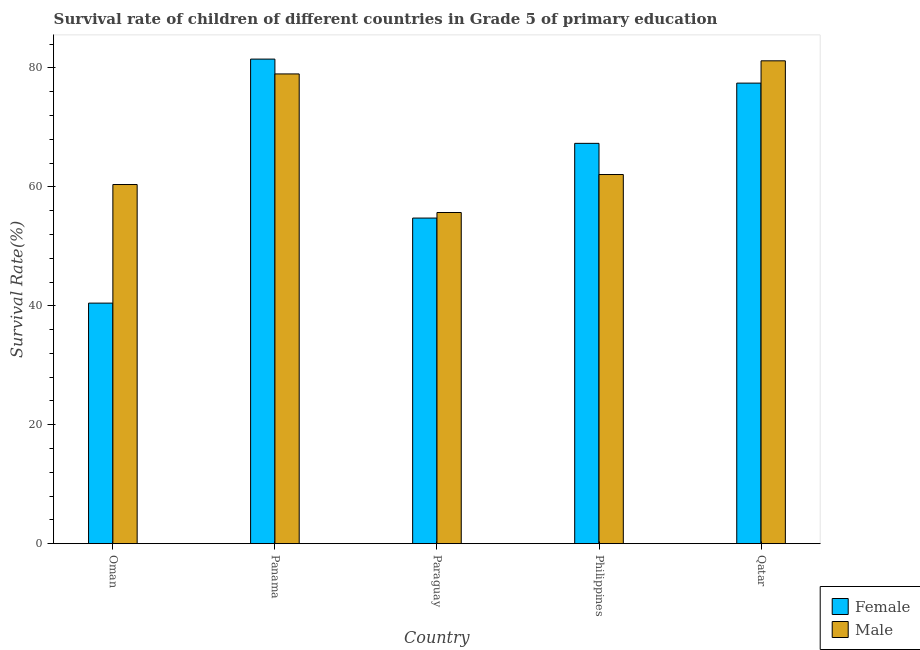How many groups of bars are there?
Give a very brief answer. 5. Are the number of bars per tick equal to the number of legend labels?
Your response must be concise. Yes. Are the number of bars on each tick of the X-axis equal?
Your answer should be very brief. Yes. What is the label of the 1st group of bars from the left?
Your answer should be very brief. Oman. What is the survival rate of female students in primary education in Oman?
Offer a very short reply. 40.45. Across all countries, what is the maximum survival rate of female students in primary education?
Offer a very short reply. 81.48. Across all countries, what is the minimum survival rate of female students in primary education?
Your answer should be compact. 40.45. In which country was the survival rate of female students in primary education maximum?
Ensure brevity in your answer.  Panama. In which country was the survival rate of female students in primary education minimum?
Keep it short and to the point. Oman. What is the total survival rate of male students in primary education in the graph?
Your answer should be compact. 338.33. What is the difference between the survival rate of male students in primary education in Philippines and that in Qatar?
Ensure brevity in your answer.  -19.12. What is the difference between the survival rate of female students in primary education in Paraguay and the survival rate of male students in primary education in Qatar?
Your response must be concise. -26.44. What is the average survival rate of male students in primary education per country?
Give a very brief answer. 67.67. What is the difference between the survival rate of male students in primary education and survival rate of female students in primary education in Philippines?
Offer a terse response. -5.24. In how many countries, is the survival rate of male students in primary education greater than 48 %?
Ensure brevity in your answer.  5. What is the ratio of the survival rate of female students in primary education in Paraguay to that in Philippines?
Give a very brief answer. 0.81. What is the difference between the highest and the second highest survival rate of male students in primary education?
Your answer should be compact. 2.21. What is the difference between the highest and the lowest survival rate of female students in primary education?
Offer a very short reply. 41.03. Is the sum of the survival rate of male students in primary education in Paraguay and Philippines greater than the maximum survival rate of female students in primary education across all countries?
Keep it short and to the point. Yes. What does the 1st bar from the right in Qatar represents?
Keep it short and to the point. Male. Are all the bars in the graph horizontal?
Provide a succinct answer. No. Are the values on the major ticks of Y-axis written in scientific E-notation?
Your answer should be very brief. No. Does the graph contain any zero values?
Provide a short and direct response. No. Does the graph contain grids?
Your answer should be compact. No. What is the title of the graph?
Offer a very short reply. Survival rate of children of different countries in Grade 5 of primary education. What is the label or title of the Y-axis?
Keep it short and to the point. Survival Rate(%). What is the Survival Rate(%) in Female in Oman?
Provide a succinct answer. 40.45. What is the Survival Rate(%) of Male in Oman?
Your response must be concise. 60.39. What is the Survival Rate(%) in Female in Panama?
Your response must be concise. 81.48. What is the Survival Rate(%) of Male in Panama?
Your answer should be compact. 78.99. What is the Survival Rate(%) in Female in Paraguay?
Keep it short and to the point. 54.75. What is the Survival Rate(%) in Male in Paraguay?
Your answer should be very brief. 55.69. What is the Survival Rate(%) of Female in Philippines?
Ensure brevity in your answer.  67.32. What is the Survival Rate(%) of Male in Philippines?
Your response must be concise. 62.07. What is the Survival Rate(%) of Female in Qatar?
Your answer should be compact. 77.44. What is the Survival Rate(%) in Male in Qatar?
Your answer should be very brief. 81.19. Across all countries, what is the maximum Survival Rate(%) of Female?
Your answer should be very brief. 81.48. Across all countries, what is the maximum Survival Rate(%) in Male?
Provide a succinct answer. 81.19. Across all countries, what is the minimum Survival Rate(%) of Female?
Give a very brief answer. 40.45. Across all countries, what is the minimum Survival Rate(%) of Male?
Ensure brevity in your answer.  55.69. What is the total Survival Rate(%) in Female in the graph?
Keep it short and to the point. 321.44. What is the total Survival Rate(%) in Male in the graph?
Offer a very short reply. 338.33. What is the difference between the Survival Rate(%) in Female in Oman and that in Panama?
Provide a short and direct response. -41.03. What is the difference between the Survival Rate(%) of Male in Oman and that in Panama?
Make the answer very short. -18.6. What is the difference between the Survival Rate(%) in Female in Oman and that in Paraguay?
Give a very brief answer. -14.3. What is the difference between the Survival Rate(%) of Male in Oman and that in Paraguay?
Offer a very short reply. 4.71. What is the difference between the Survival Rate(%) in Female in Oman and that in Philippines?
Offer a terse response. -26.87. What is the difference between the Survival Rate(%) of Male in Oman and that in Philippines?
Make the answer very short. -1.68. What is the difference between the Survival Rate(%) of Female in Oman and that in Qatar?
Ensure brevity in your answer.  -36.99. What is the difference between the Survival Rate(%) in Male in Oman and that in Qatar?
Provide a short and direct response. -20.8. What is the difference between the Survival Rate(%) in Female in Panama and that in Paraguay?
Make the answer very short. 26.73. What is the difference between the Survival Rate(%) in Male in Panama and that in Paraguay?
Offer a very short reply. 23.3. What is the difference between the Survival Rate(%) in Female in Panama and that in Philippines?
Make the answer very short. 14.17. What is the difference between the Survival Rate(%) in Male in Panama and that in Philippines?
Provide a short and direct response. 16.92. What is the difference between the Survival Rate(%) in Female in Panama and that in Qatar?
Your answer should be compact. 4.04. What is the difference between the Survival Rate(%) in Male in Panama and that in Qatar?
Provide a short and direct response. -2.21. What is the difference between the Survival Rate(%) of Female in Paraguay and that in Philippines?
Offer a terse response. -12.57. What is the difference between the Survival Rate(%) in Male in Paraguay and that in Philippines?
Keep it short and to the point. -6.39. What is the difference between the Survival Rate(%) in Female in Paraguay and that in Qatar?
Give a very brief answer. -22.69. What is the difference between the Survival Rate(%) of Male in Paraguay and that in Qatar?
Your answer should be very brief. -25.51. What is the difference between the Survival Rate(%) of Female in Philippines and that in Qatar?
Offer a terse response. -10.13. What is the difference between the Survival Rate(%) of Male in Philippines and that in Qatar?
Keep it short and to the point. -19.12. What is the difference between the Survival Rate(%) of Female in Oman and the Survival Rate(%) of Male in Panama?
Your answer should be very brief. -38.54. What is the difference between the Survival Rate(%) in Female in Oman and the Survival Rate(%) in Male in Paraguay?
Offer a very short reply. -15.24. What is the difference between the Survival Rate(%) of Female in Oman and the Survival Rate(%) of Male in Philippines?
Make the answer very short. -21.62. What is the difference between the Survival Rate(%) of Female in Oman and the Survival Rate(%) of Male in Qatar?
Provide a short and direct response. -40.74. What is the difference between the Survival Rate(%) in Female in Panama and the Survival Rate(%) in Male in Paraguay?
Offer a terse response. 25.8. What is the difference between the Survival Rate(%) of Female in Panama and the Survival Rate(%) of Male in Philippines?
Offer a very short reply. 19.41. What is the difference between the Survival Rate(%) in Female in Panama and the Survival Rate(%) in Male in Qatar?
Keep it short and to the point. 0.29. What is the difference between the Survival Rate(%) of Female in Paraguay and the Survival Rate(%) of Male in Philippines?
Offer a terse response. -7.32. What is the difference between the Survival Rate(%) of Female in Paraguay and the Survival Rate(%) of Male in Qatar?
Your answer should be compact. -26.44. What is the difference between the Survival Rate(%) in Female in Philippines and the Survival Rate(%) in Male in Qatar?
Offer a terse response. -13.88. What is the average Survival Rate(%) in Female per country?
Your answer should be very brief. 64.29. What is the average Survival Rate(%) in Male per country?
Your answer should be compact. 67.67. What is the difference between the Survival Rate(%) in Female and Survival Rate(%) in Male in Oman?
Offer a terse response. -19.94. What is the difference between the Survival Rate(%) in Female and Survival Rate(%) in Male in Panama?
Make the answer very short. 2.49. What is the difference between the Survival Rate(%) in Female and Survival Rate(%) in Male in Paraguay?
Keep it short and to the point. -0.94. What is the difference between the Survival Rate(%) in Female and Survival Rate(%) in Male in Philippines?
Offer a terse response. 5.24. What is the difference between the Survival Rate(%) in Female and Survival Rate(%) in Male in Qatar?
Make the answer very short. -3.75. What is the ratio of the Survival Rate(%) in Female in Oman to that in Panama?
Ensure brevity in your answer.  0.5. What is the ratio of the Survival Rate(%) of Male in Oman to that in Panama?
Ensure brevity in your answer.  0.76. What is the ratio of the Survival Rate(%) in Female in Oman to that in Paraguay?
Make the answer very short. 0.74. What is the ratio of the Survival Rate(%) in Male in Oman to that in Paraguay?
Ensure brevity in your answer.  1.08. What is the ratio of the Survival Rate(%) of Female in Oman to that in Philippines?
Ensure brevity in your answer.  0.6. What is the ratio of the Survival Rate(%) of Male in Oman to that in Philippines?
Make the answer very short. 0.97. What is the ratio of the Survival Rate(%) in Female in Oman to that in Qatar?
Keep it short and to the point. 0.52. What is the ratio of the Survival Rate(%) in Male in Oman to that in Qatar?
Keep it short and to the point. 0.74. What is the ratio of the Survival Rate(%) of Female in Panama to that in Paraguay?
Provide a succinct answer. 1.49. What is the ratio of the Survival Rate(%) in Male in Panama to that in Paraguay?
Provide a succinct answer. 1.42. What is the ratio of the Survival Rate(%) in Female in Panama to that in Philippines?
Keep it short and to the point. 1.21. What is the ratio of the Survival Rate(%) in Male in Panama to that in Philippines?
Offer a very short reply. 1.27. What is the ratio of the Survival Rate(%) in Female in Panama to that in Qatar?
Provide a succinct answer. 1.05. What is the ratio of the Survival Rate(%) in Male in Panama to that in Qatar?
Offer a very short reply. 0.97. What is the ratio of the Survival Rate(%) in Female in Paraguay to that in Philippines?
Provide a short and direct response. 0.81. What is the ratio of the Survival Rate(%) in Male in Paraguay to that in Philippines?
Offer a very short reply. 0.9. What is the ratio of the Survival Rate(%) in Female in Paraguay to that in Qatar?
Your answer should be compact. 0.71. What is the ratio of the Survival Rate(%) of Male in Paraguay to that in Qatar?
Your answer should be very brief. 0.69. What is the ratio of the Survival Rate(%) in Female in Philippines to that in Qatar?
Give a very brief answer. 0.87. What is the ratio of the Survival Rate(%) in Male in Philippines to that in Qatar?
Ensure brevity in your answer.  0.76. What is the difference between the highest and the second highest Survival Rate(%) in Female?
Give a very brief answer. 4.04. What is the difference between the highest and the second highest Survival Rate(%) in Male?
Provide a short and direct response. 2.21. What is the difference between the highest and the lowest Survival Rate(%) of Female?
Keep it short and to the point. 41.03. What is the difference between the highest and the lowest Survival Rate(%) of Male?
Make the answer very short. 25.51. 